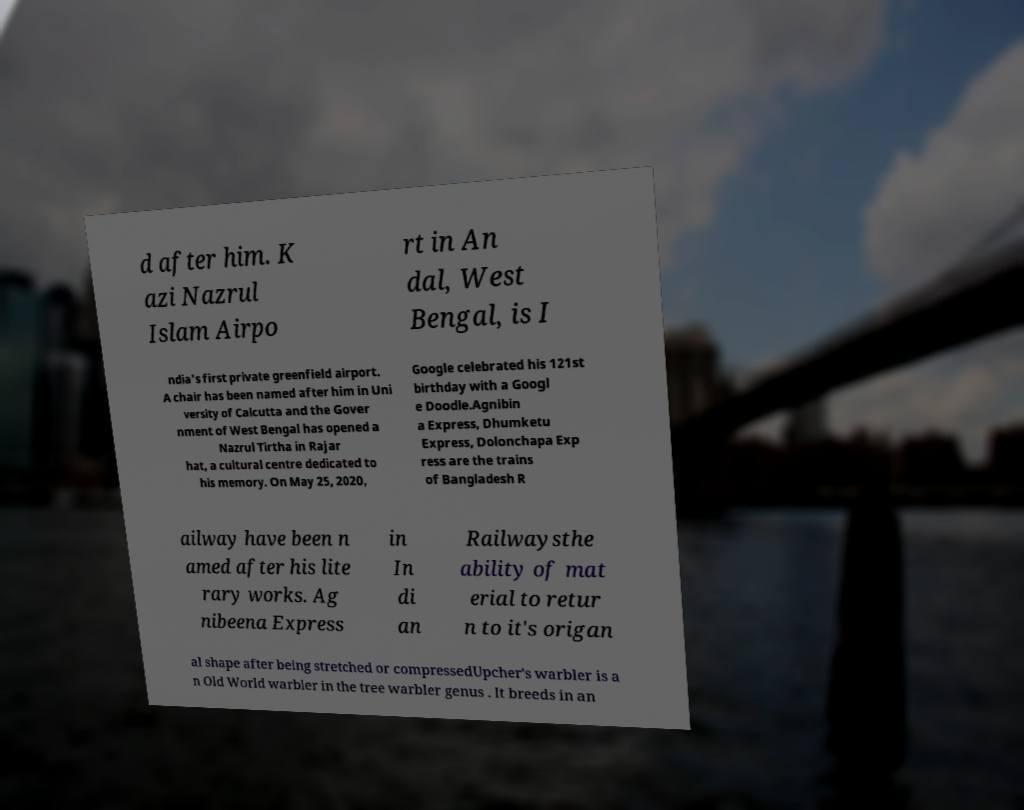Please identify and transcribe the text found in this image. d after him. K azi Nazrul Islam Airpo rt in An dal, West Bengal, is I ndia's first private greenfield airport. A chair has been named after him in Uni versity of Calcutta and the Gover nment of West Bengal has opened a Nazrul Tirtha in Rajar hat, a cultural centre dedicated to his memory. On May 25, 2020, Google celebrated his 121st birthday with a Googl e Doodle.Agnibin a Express, Dhumketu Express, Dolonchapa Exp ress are the trains of Bangladesh R ailway have been n amed after his lite rary works. Ag nibeena Express in In di an Railwaysthe ability of mat erial to retur n to it's origan al shape after being stretched or compressedUpcher's warbler is a n Old World warbler in the tree warbler genus . It breeds in an 